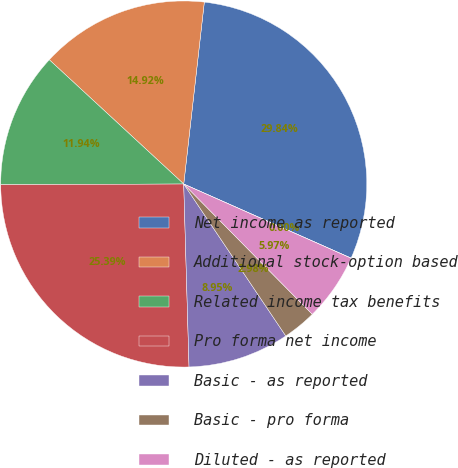Convert chart. <chart><loc_0><loc_0><loc_500><loc_500><pie_chart><fcel>Net income as reported<fcel>Additional stock-option based<fcel>Related income tax benefits<fcel>Pro forma net income<fcel>Basic - as reported<fcel>Basic - pro forma<fcel>Diluted - as reported<fcel>Diluted - pro forma<nl><fcel>29.84%<fcel>14.92%<fcel>11.94%<fcel>25.39%<fcel>8.95%<fcel>2.98%<fcel>5.97%<fcel>0.0%<nl></chart> 